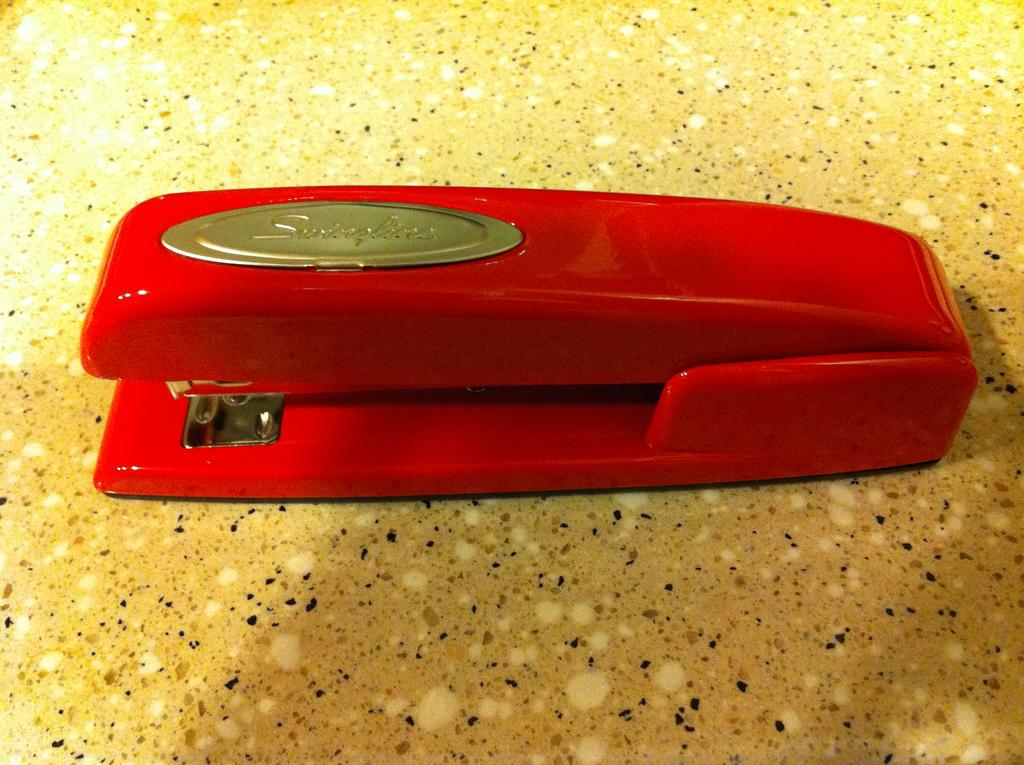What object can be seen in the image? There is a stapler in the image. What is the color of the stapler? The stapler is red in color. Is there anything on the stapler? Yes, there is a batch on the stapler. What type of texture does the chicken have in the image? There is no chicken present in the image, so it is not possible to determine its texture. 